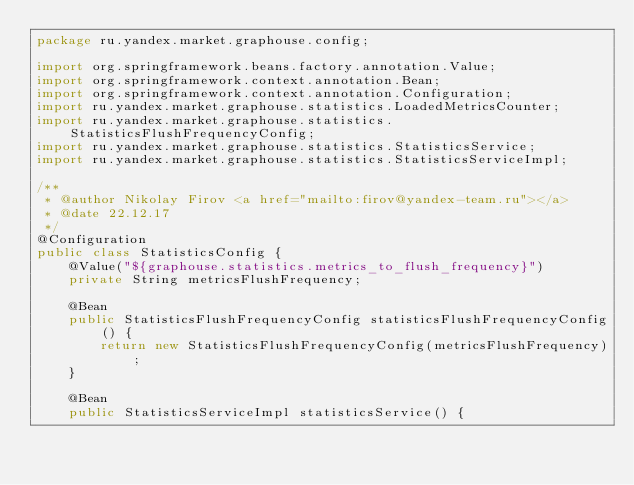Convert code to text. <code><loc_0><loc_0><loc_500><loc_500><_Java_>package ru.yandex.market.graphouse.config;

import org.springframework.beans.factory.annotation.Value;
import org.springframework.context.annotation.Bean;
import org.springframework.context.annotation.Configuration;
import ru.yandex.market.graphouse.statistics.LoadedMetricsCounter;
import ru.yandex.market.graphouse.statistics.StatisticsFlushFrequencyConfig;
import ru.yandex.market.graphouse.statistics.StatisticsService;
import ru.yandex.market.graphouse.statistics.StatisticsServiceImpl;

/**
 * @author Nikolay Firov <a href="mailto:firov@yandex-team.ru"></a>
 * @date 22.12.17
 */
@Configuration
public class StatisticsConfig {
    @Value("${graphouse.statistics.metrics_to_flush_frequency}")
    private String metricsFlushFrequency;

    @Bean
    public StatisticsFlushFrequencyConfig statisticsFlushFrequencyConfig() {
        return new StatisticsFlushFrequencyConfig(metricsFlushFrequency);
    }

    @Bean
    public StatisticsServiceImpl statisticsService() {</code> 